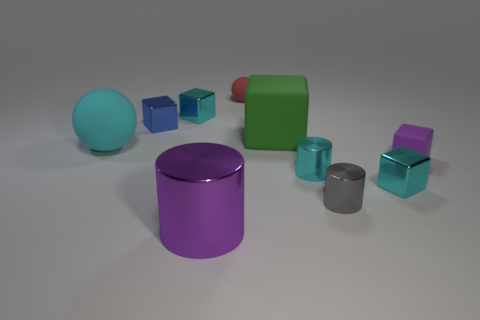Subtract all purple cubes. How many cubes are left? 4 Subtract all tiny rubber cubes. How many cubes are left? 4 Subtract all brown blocks. Subtract all gray cylinders. How many blocks are left? 5 Subtract all spheres. How many objects are left? 8 Add 6 small red rubber things. How many small red rubber things are left? 7 Add 3 small purple shiny cylinders. How many small purple shiny cylinders exist? 3 Subtract 1 purple cubes. How many objects are left? 9 Subtract all red spheres. Subtract all purple things. How many objects are left? 7 